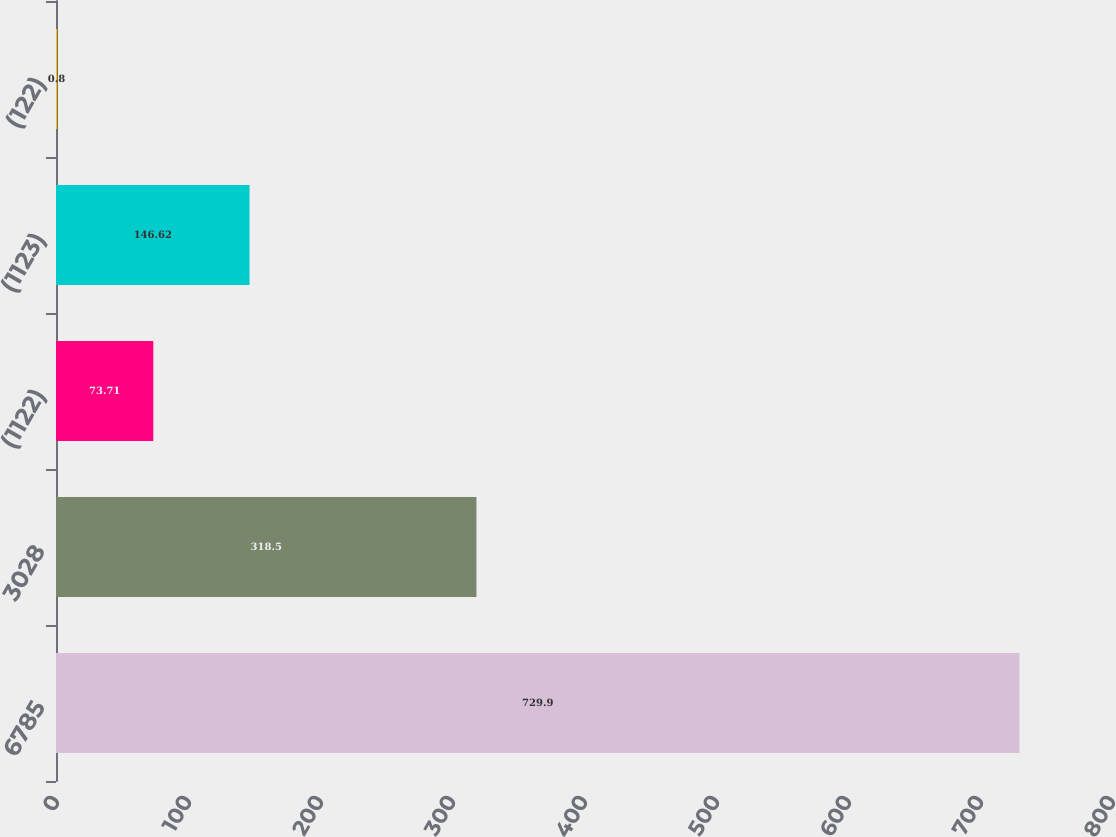<chart> <loc_0><loc_0><loc_500><loc_500><bar_chart><fcel>6785<fcel>3028<fcel>(1122)<fcel>(1123)<fcel>(122)<nl><fcel>729.9<fcel>318.5<fcel>73.71<fcel>146.62<fcel>0.8<nl></chart> 